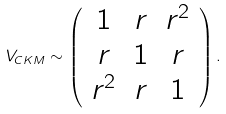<formula> <loc_0><loc_0><loc_500><loc_500>V _ { C K M } \sim \left ( \begin{array} { c c c } 1 & r & r ^ { 2 } \\ r & 1 & r \\ r ^ { 2 } & r & 1 \end{array} \right ) .</formula> 